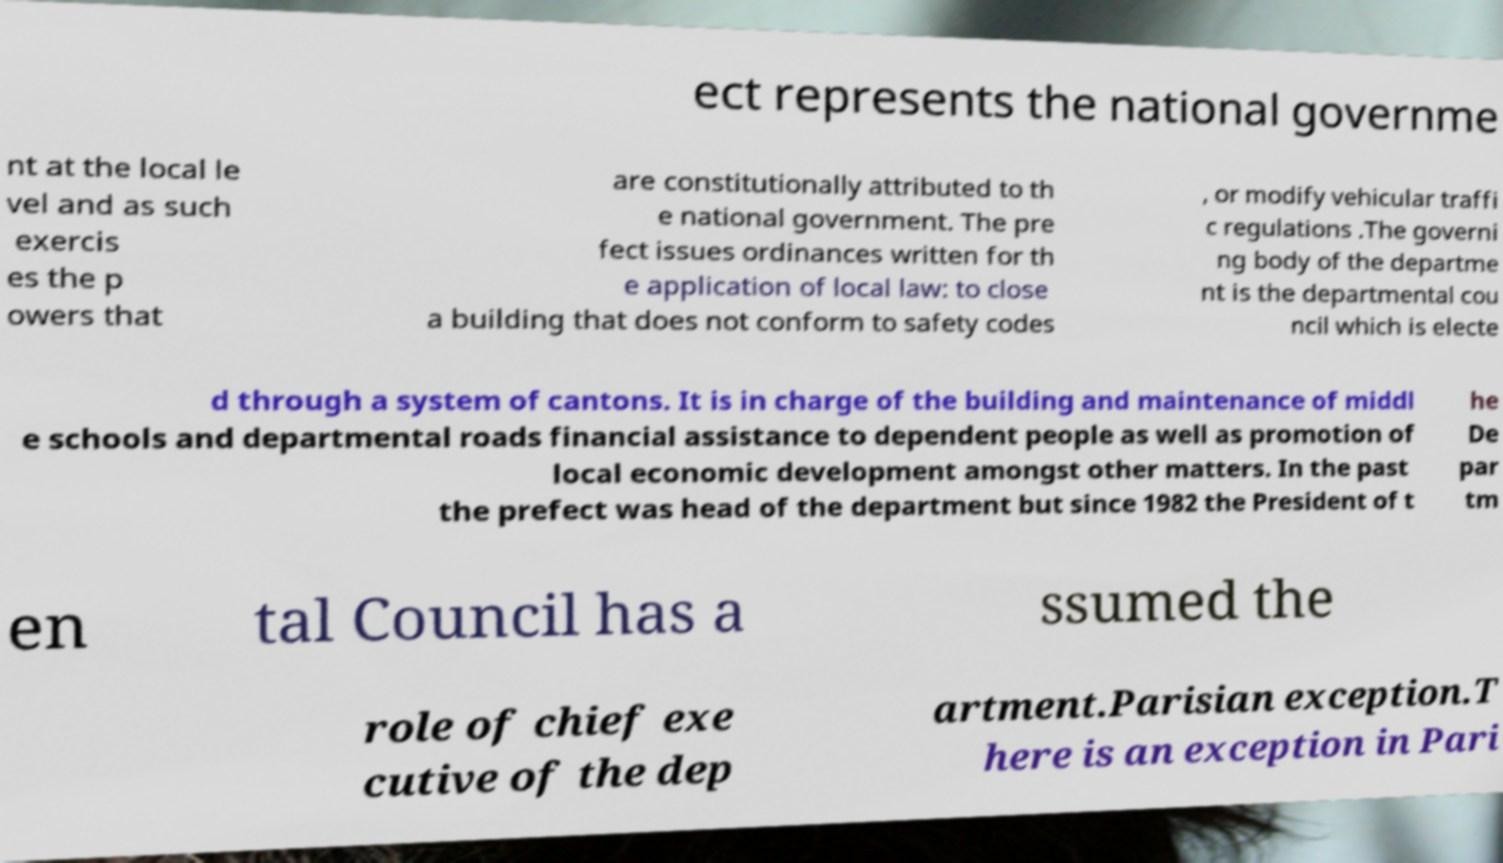Please read and relay the text visible in this image. What does it say? ect represents the national governme nt at the local le vel and as such exercis es the p owers that are constitutionally attributed to th e national government. The pre fect issues ordinances written for th e application of local law: to close a building that does not conform to safety codes , or modify vehicular traffi c regulations .The governi ng body of the departme nt is the departmental cou ncil which is electe d through a system of cantons. It is in charge of the building and maintenance of middl e schools and departmental roads financial assistance to dependent people as well as promotion of local economic development amongst other matters. In the past the prefect was head of the department but since 1982 the President of t he De par tm en tal Council has a ssumed the role of chief exe cutive of the dep artment.Parisian exception.T here is an exception in Pari 